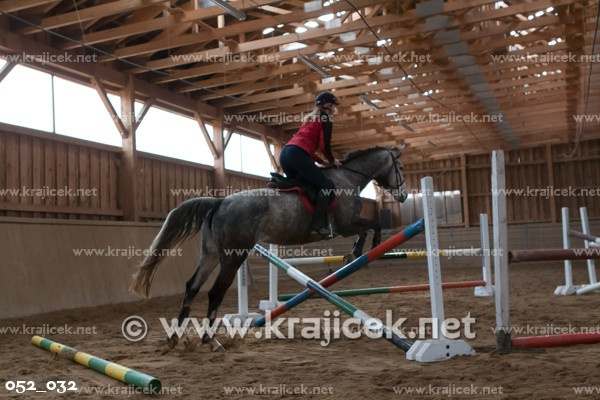Describe the objects in this image and their specific colors. I can see horse in black and gray tones and people in black, maroon, gray, and brown tones in this image. 